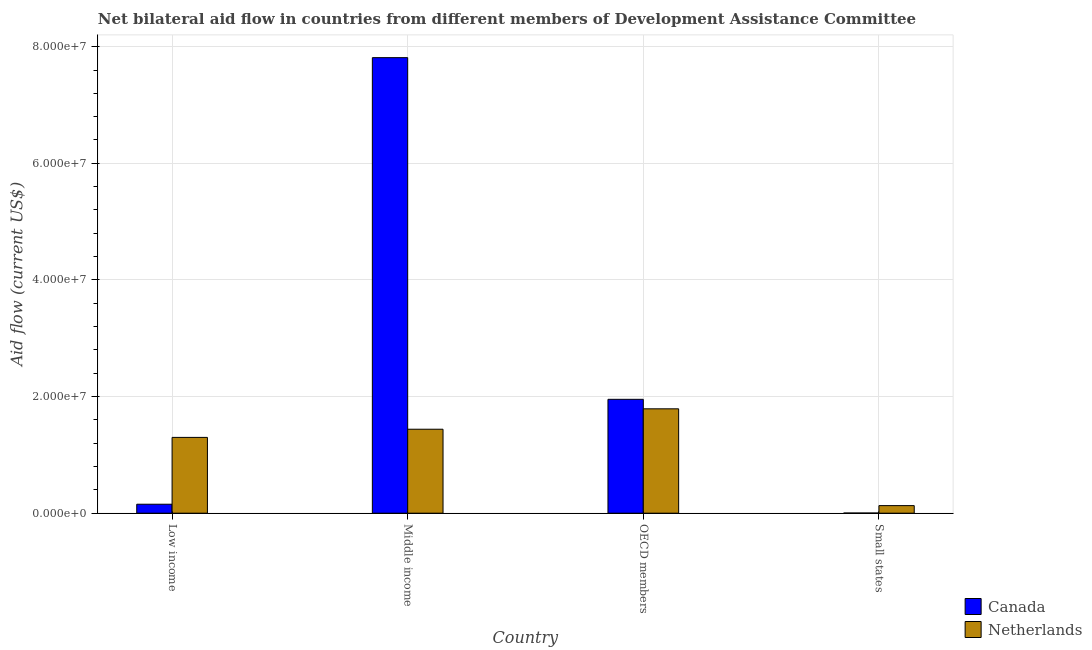How many different coloured bars are there?
Your response must be concise. 2. Are the number of bars on each tick of the X-axis equal?
Offer a very short reply. Yes. How many bars are there on the 4th tick from the left?
Provide a short and direct response. 2. What is the label of the 1st group of bars from the left?
Give a very brief answer. Low income. In how many cases, is the number of bars for a given country not equal to the number of legend labels?
Keep it short and to the point. 0. What is the amount of aid given by netherlands in Middle income?
Offer a very short reply. 1.44e+07. Across all countries, what is the maximum amount of aid given by canada?
Ensure brevity in your answer.  7.81e+07. Across all countries, what is the minimum amount of aid given by netherlands?
Offer a terse response. 1.30e+06. In which country was the amount of aid given by canada maximum?
Your answer should be very brief. Middle income. In which country was the amount of aid given by canada minimum?
Keep it short and to the point. Small states. What is the total amount of aid given by netherlands in the graph?
Give a very brief answer. 4.66e+07. What is the difference between the amount of aid given by netherlands in Middle income and that in Small states?
Ensure brevity in your answer.  1.31e+07. What is the difference between the amount of aid given by canada in Small states and the amount of aid given by netherlands in Low income?
Provide a succinct answer. -1.30e+07. What is the average amount of aid given by canada per country?
Provide a short and direct response. 2.48e+07. What is the difference between the amount of aid given by netherlands and amount of aid given by canada in OECD members?
Offer a terse response. -1.63e+06. What is the ratio of the amount of aid given by netherlands in Middle income to that in Small states?
Offer a terse response. 11.08. Is the amount of aid given by netherlands in Low income less than that in OECD members?
Your answer should be very brief. Yes. Is the difference between the amount of aid given by netherlands in Middle income and Small states greater than the difference between the amount of aid given by canada in Middle income and Small states?
Your answer should be compact. No. What is the difference between the highest and the second highest amount of aid given by canada?
Provide a succinct answer. 5.86e+07. What is the difference between the highest and the lowest amount of aid given by canada?
Provide a short and direct response. 7.81e+07. What does the 2nd bar from the right in OECD members represents?
Your answer should be very brief. Canada. Are all the bars in the graph horizontal?
Ensure brevity in your answer.  No. How many countries are there in the graph?
Provide a short and direct response. 4. Does the graph contain any zero values?
Your answer should be very brief. No. Does the graph contain grids?
Provide a short and direct response. Yes. What is the title of the graph?
Provide a succinct answer. Net bilateral aid flow in countries from different members of Development Assistance Committee. Does "% of GNI" appear as one of the legend labels in the graph?
Offer a very short reply. No. What is the label or title of the X-axis?
Your answer should be compact. Country. What is the Aid flow (current US$) in Canada in Low income?
Ensure brevity in your answer.  1.54e+06. What is the Aid flow (current US$) in Netherlands in Low income?
Provide a succinct answer. 1.30e+07. What is the Aid flow (current US$) of Canada in Middle income?
Offer a terse response. 7.81e+07. What is the Aid flow (current US$) in Netherlands in Middle income?
Keep it short and to the point. 1.44e+07. What is the Aid flow (current US$) in Canada in OECD members?
Make the answer very short. 1.95e+07. What is the Aid flow (current US$) of Netherlands in OECD members?
Offer a very short reply. 1.79e+07. What is the Aid flow (current US$) of Netherlands in Small states?
Your response must be concise. 1.30e+06. Across all countries, what is the maximum Aid flow (current US$) in Canada?
Your answer should be very brief. 7.81e+07. Across all countries, what is the maximum Aid flow (current US$) of Netherlands?
Keep it short and to the point. 1.79e+07. Across all countries, what is the minimum Aid flow (current US$) in Canada?
Provide a succinct answer. 3.00e+04. Across all countries, what is the minimum Aid flow (current US$) in Netherlands?
Make the answer very short. 1.30e+06. What is the total Aid flow (current US$) in Canada in the graph?
Keep it short and to the point. 9.92e+07. What is the total Aid flow (current US$) of Netherlands in the graph?
Your answer should be very brief. 4.66e+07. What is the difference between the Aid flow (current US$) in Canada in Low income and that in Middle income?
Offer a terse response. -7.66e+07. What is the difference between the Aid flow (current US$) of Netherlands in Low income and that in Middle income?
Keep it short and to the point. -1.40e+06. What is the difference between the Aid flow (current US$) in Canada in Low income and that in OECD members?
Provide a short and direct response. -1.80e+07. What is the difference between the Aid flow (current US$) in Netherlands in Low income and that in OECD members?
Offer a terse response. -4.90e+06. What is the difference between the Aid flow (current US$) in Canada in Low income and that in Small states?
Offer a terse response. 1.51e+06. What is the difference between the Aid flow (current US$) in Netherlands in Low income and that in Small states?
Your answer should be very brief. 1.17e+07. What is the difference between the Aid flow (current US$) in Canada in Middle income and that in OECD members?
Offer a very short reply. 5.86e+07. What is the difference between the Aid flow (current US$) of Netherlands in Middle income and that in OECD members?
Your response must be concise. -3.50e+06. What is the difference between the Aid flow (current US$) of Canada in Middle income and that in Small states?
Keep it short and to the point. 7.81e+07. What is the difference between the Aid flow (current US$) of Netherlands in Middle income and that in Small states?
Your answer should be very brief. 1.31e+07. What is the difference between the Aid flow (current US$) of Canada in OECD members and that in Small states?
Your answer should be very brief. 1.95e+07. What is the difference between the Aid flow (current US$) of Netherlands in OECD members and that in Small states?
Provide a succinct answer. 1.66e+07. What is the difference between the Aid flow (current US$) of Canada in Low income and the Aid flow (current US$) of Netherlands in Middle income?
Your response must be concise. -1.29e+07. What is the difference between the Aid flow (current US$) of Canada in Low income and the Aid flow (current US$) of Netherlands in OECD members?
Offer a terse response. -1.64e+07. What is the difference between the Aid flow (current US$) in Canada in Middle income and the Aid flow (current US$) in Netherlands in OECD members?
Ensure brevity in your answer.  6.02e+07. What is the difference between the Aid flow (current US$) of Canada in Middle income and the Aid flow (current US$) of Netherlands in Small states?
Give a very brief answer. 7.68e+07. What is the difference between the Aid flow (current US$) of Canada in OECD members and the Aid flow (current US$) of Netherlands in Small states?
Make the answer very short. 1.82e+07. What is the average Aid flow (current US$) in Canada per country?
Offer a terse response. 2.48e+07. What is the average Aid flow (current US$) of Netherlands per country?
Make the answer very short. 1.16e+07. What is the difference between the Aid flow (current US$) of Canada and Aid flow (current US$) of Netherlands in Low income?
Offer a terse response. -1.15e+07. What is the difference between the Aid flow (current US$) in Canada and Aid flow (current US$) in Netherlands in Middle income?
Make the answer very short. 6.37e+07. What is the difference between the Aid flow (current US$) in Canada and Aid flow (current US$) in Netherlands in OECD members?
Your answer should be compact. 1.63e+06. What is the difference between the Aid flow (current US$) in Canada and Aid flow (current US$) in Netherlands in Small states?
Your answer should be very brief. -1.27e+06. What is the ratio of the Aid flow (current US$) of Canada in Low income to that in Middle income?
Provide a succinct answer. 0.02. What is the ratio of the Aid flow (current US$) of Netherlands in Low income to that in Middle income?
Provide a short and direct response. 0.9. What is the ratio of the Aid flow (current US$) in Canada in Low income to that in OECD members?
Offer a terse response. 0.08. What is the ratio of the Aid flow (current US$) of Netherlands in Low income to that in OECD members?
Offer a very short reply. 0.73. What is the ratio of the Aid flow (current US$) in Canada in Low income to that in Small states?
Your response must be concise. 51.33. What is the ratio of the Aid flow (current US$) in Canada in Middle income to that in OECD members?
Make the answer very short. 4. What is the ratio of the Aid flow (current US$) in Netherlands in Middle income to that in OECD members?
Make the answer very short. 0.8. What is the ratio of the Aid flow (current US$) in Canada in Middle income to that in Small states?
Offer a terse response. 2604. What is the ratio of the Aid flow (current US$) of Netherlands in Middle income to that in Small states?
Your answer should be compact. 11.08. What is the ratio of the Aid flow (current US$) in Canada in OECD members to that in Small states?
Provide a short and direct response. 651. What is the ratio of the Aid flow (current US$) in Netherlands in OECD members to that in Small states?
Give a very brief answer. 13.77. What is the difference between the highest and the second highest Aid flow (current US$) in Canada?
Make the answer very short. 5.86e+07. What is the difference between the highest and the second highest Aid flow (current US$) of Netherlands?
Make the answer very short. 3.50e+06. What is the difference between the highest and the lowest Aid flow (current US$) in Canada?
Offer a terse response. 7.81e+07. What is the difference between the highest and the lowest Aid flow (current US$) of Netherlands?
Provide a succinct answer. 1.66e+07. 